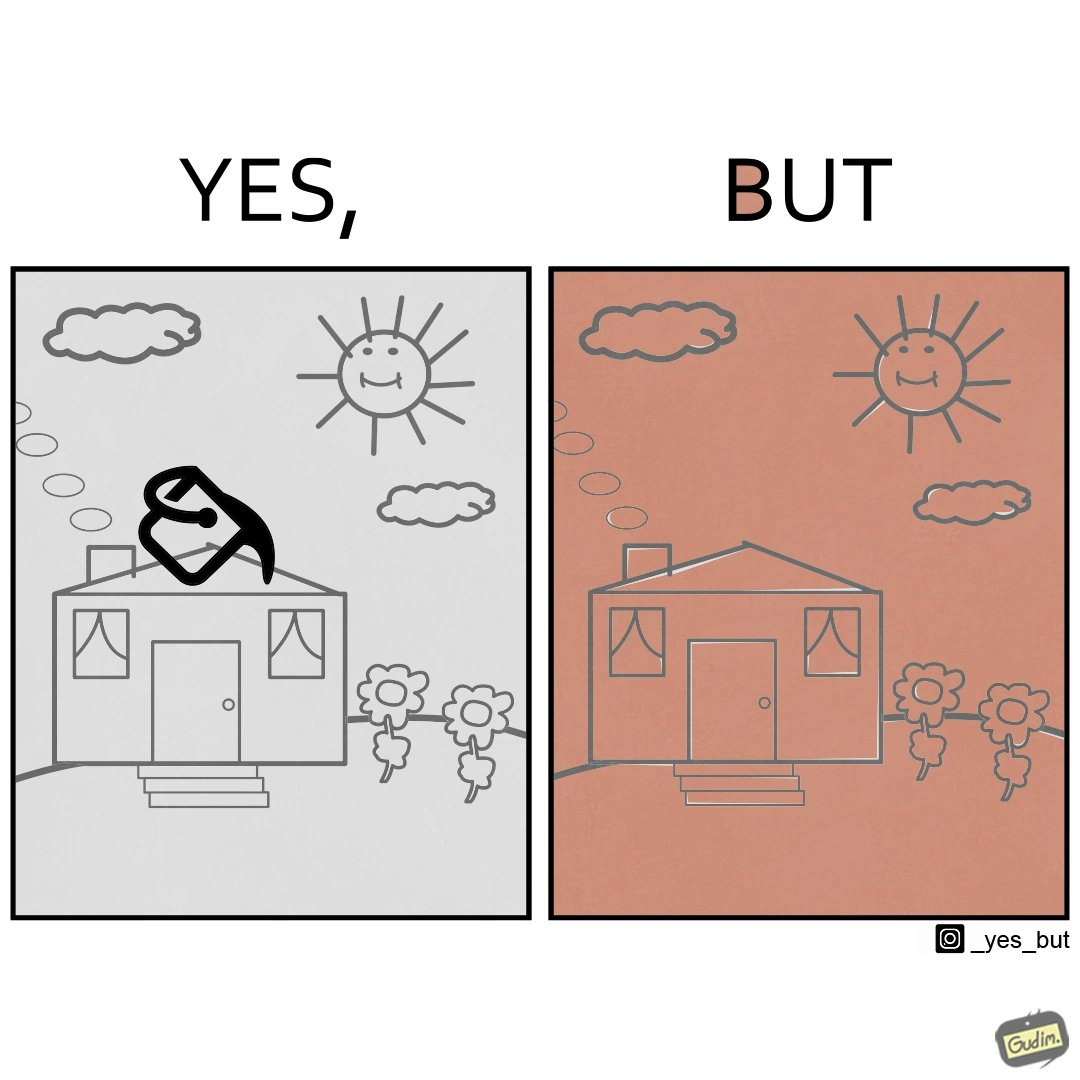What makes this image funny or satirical? The image is funny and showing a common problem with microsoft paint like applications where even a slight openings in the shapes causes entire drawing to be filled with the same color when using the fill color option. In this case, the person using the application intended to color only the ceiling of the house to brick red but ended up coloring the whole drawing with the brick red color. 